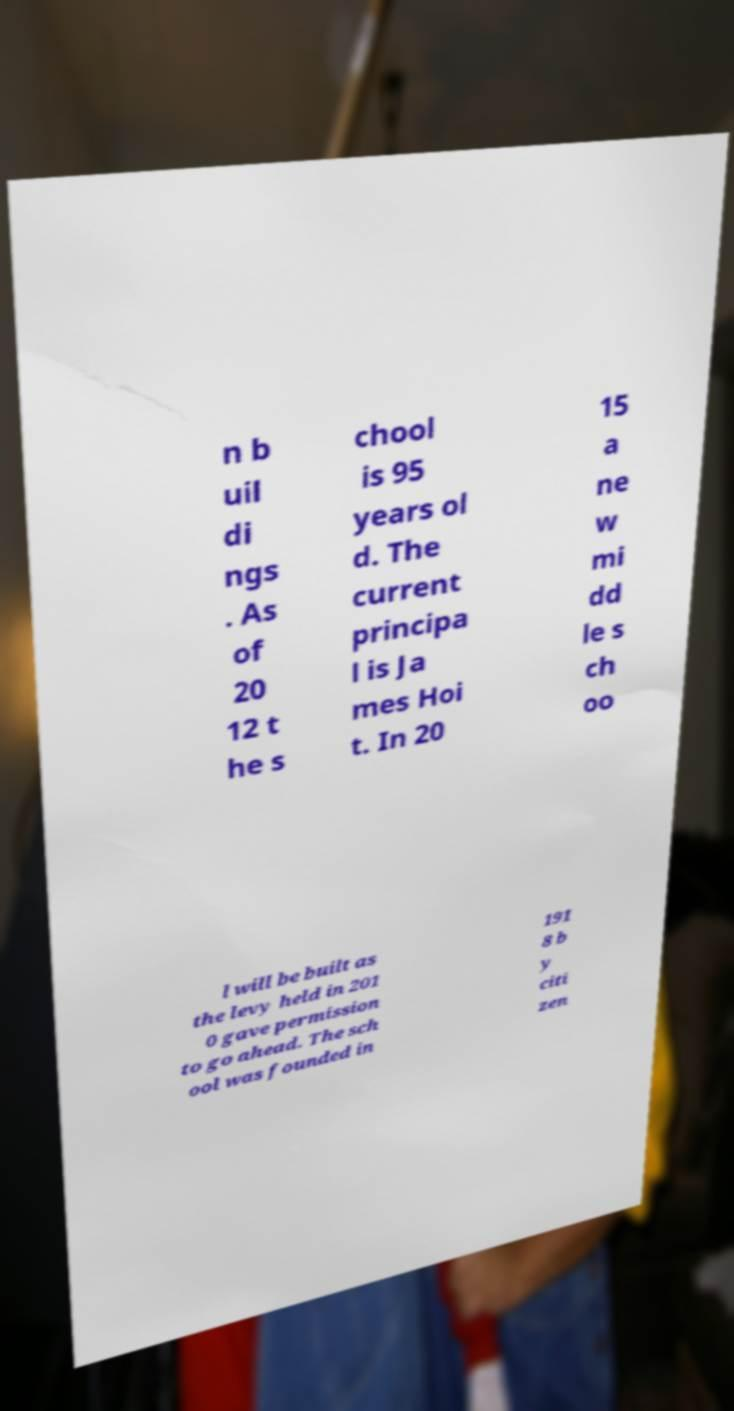Can you read and provide the text displayed in the image?This photo seems to have some interesting text. Can you extract and type it out for me? n b uil di ngs . As of 20 12 t he s chool is 95 years ol d. The current principa l is Ja mes Hoi t. In 20 15 a ne w mi dd le s ch oo l will be built as the levy held in 201 0 gave permission to go ahead. The sch ool was founded in 191 8 b y citi zen 